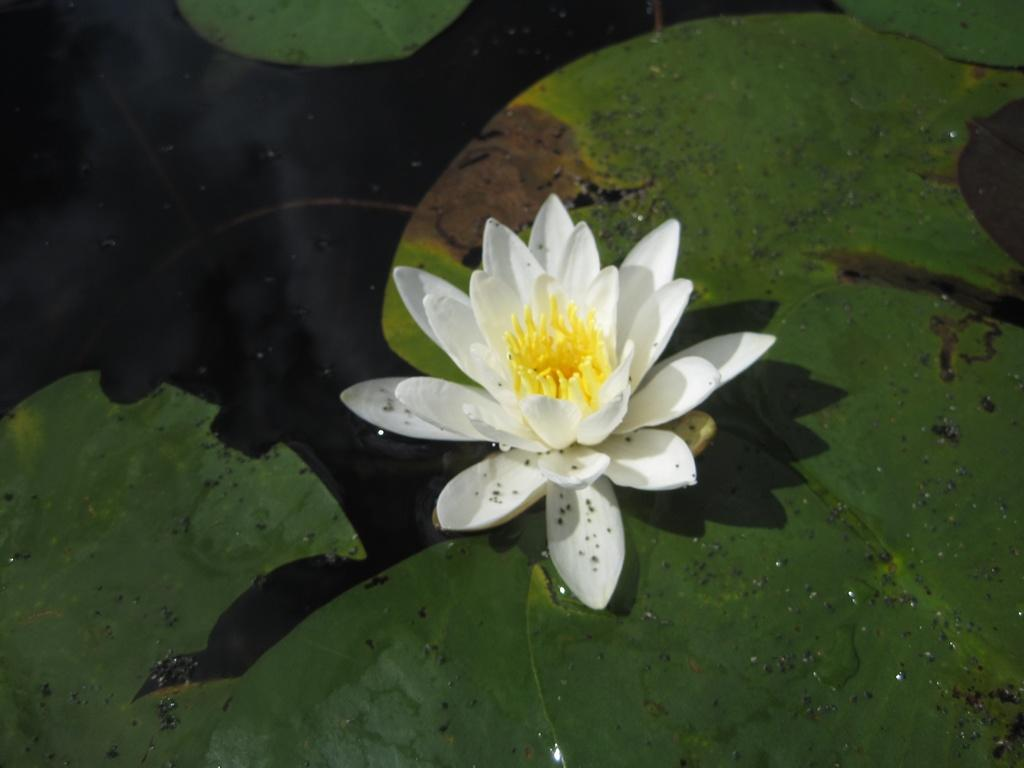What is the main subject of the image? There is a white lotus flower in the middle of the image. What is the color of the lotus flower? The lotus flower is white. What else can be seen in the image besides the lotus flower? There are green leaves floating on the water. What type of chicken is resting on the lotus flower in the image? There is no chicken present in the image; it features a white lotus flower and green leaves floating on the water. 